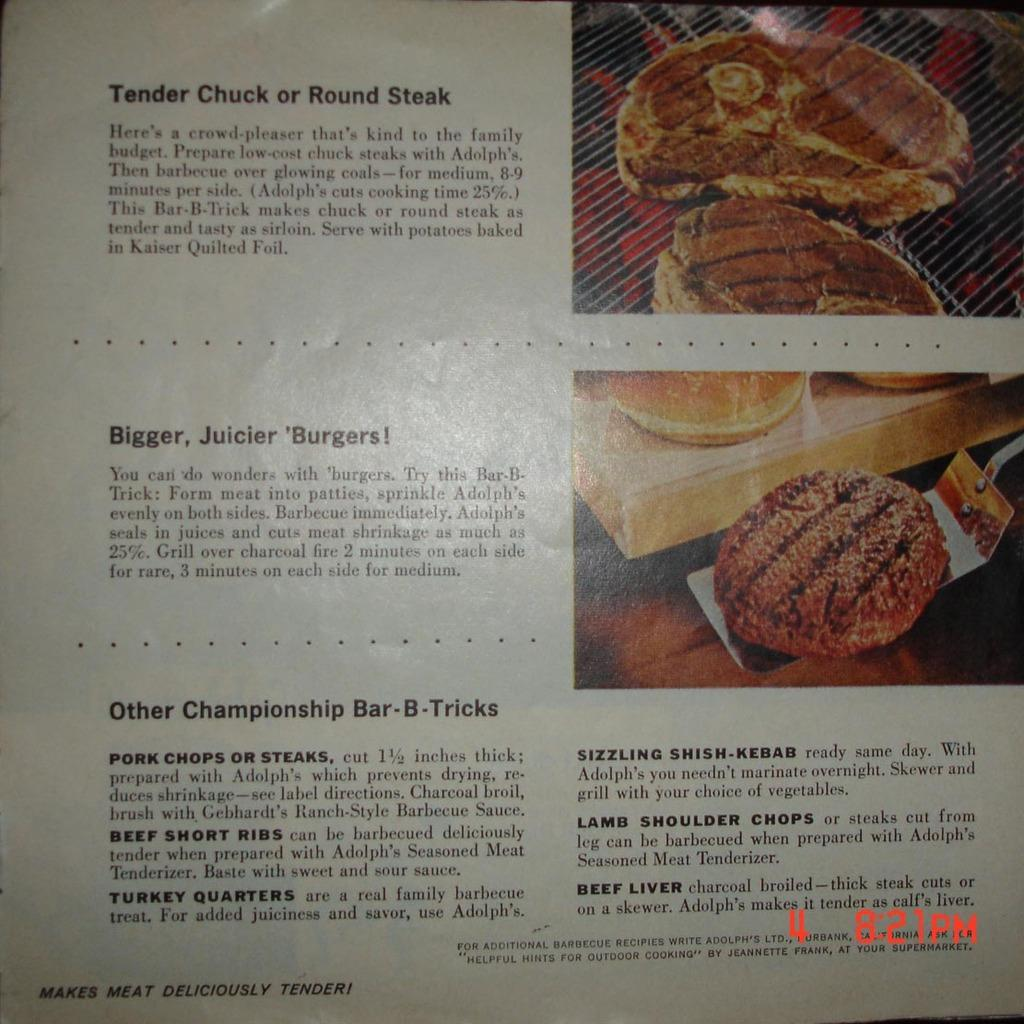What is present in the image that contains visuals and information? There is a poster in the image that contains images and text. Can you describe the content of the poster? The poster contains images and text, but the specific content is not mentioned in the provided facts. Where can the time be found in the image? The time is displayed in the bottom right corner of the image. What type of shoe is the grandfather wearing in the image? There is no grandfather or shoe present in the image; it only contains a poster with images and text, and a time display in the bottom right corner. 